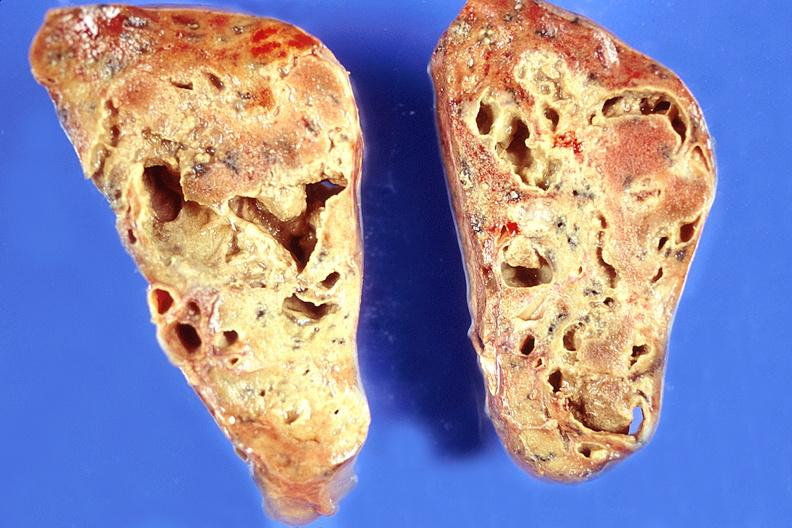s respiratory present?
Answer the question using a single word or phrase. Yes 